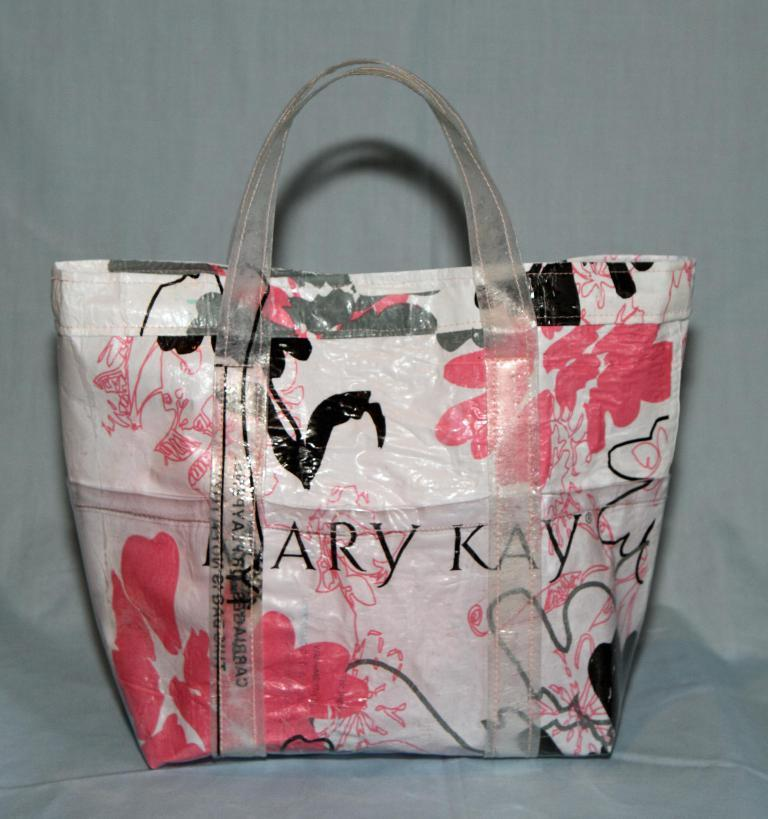What object is on the floor in the image? There is a bag on the floor in the image. Can you describe the colors of the bag? The bag has multiple colors: white, pink, black, and ash. What text is visible on the bag? The text on the bag says "Mary Kay." What color is the background of the image? The background of the image is ash in color. Where is the wren perched in the image? There is no wren present in the image. What type of spoon is being used to stir the ash in the image? There is no spoon or stirring activity in the image; it only features a bag on the floor. 